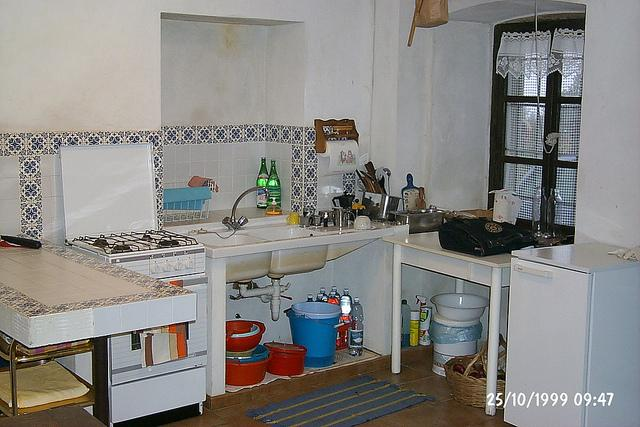What is the large circular blue object under the sink? Please explain your reasoning. bucket. The design and the plastic its made of shows you what it is. 